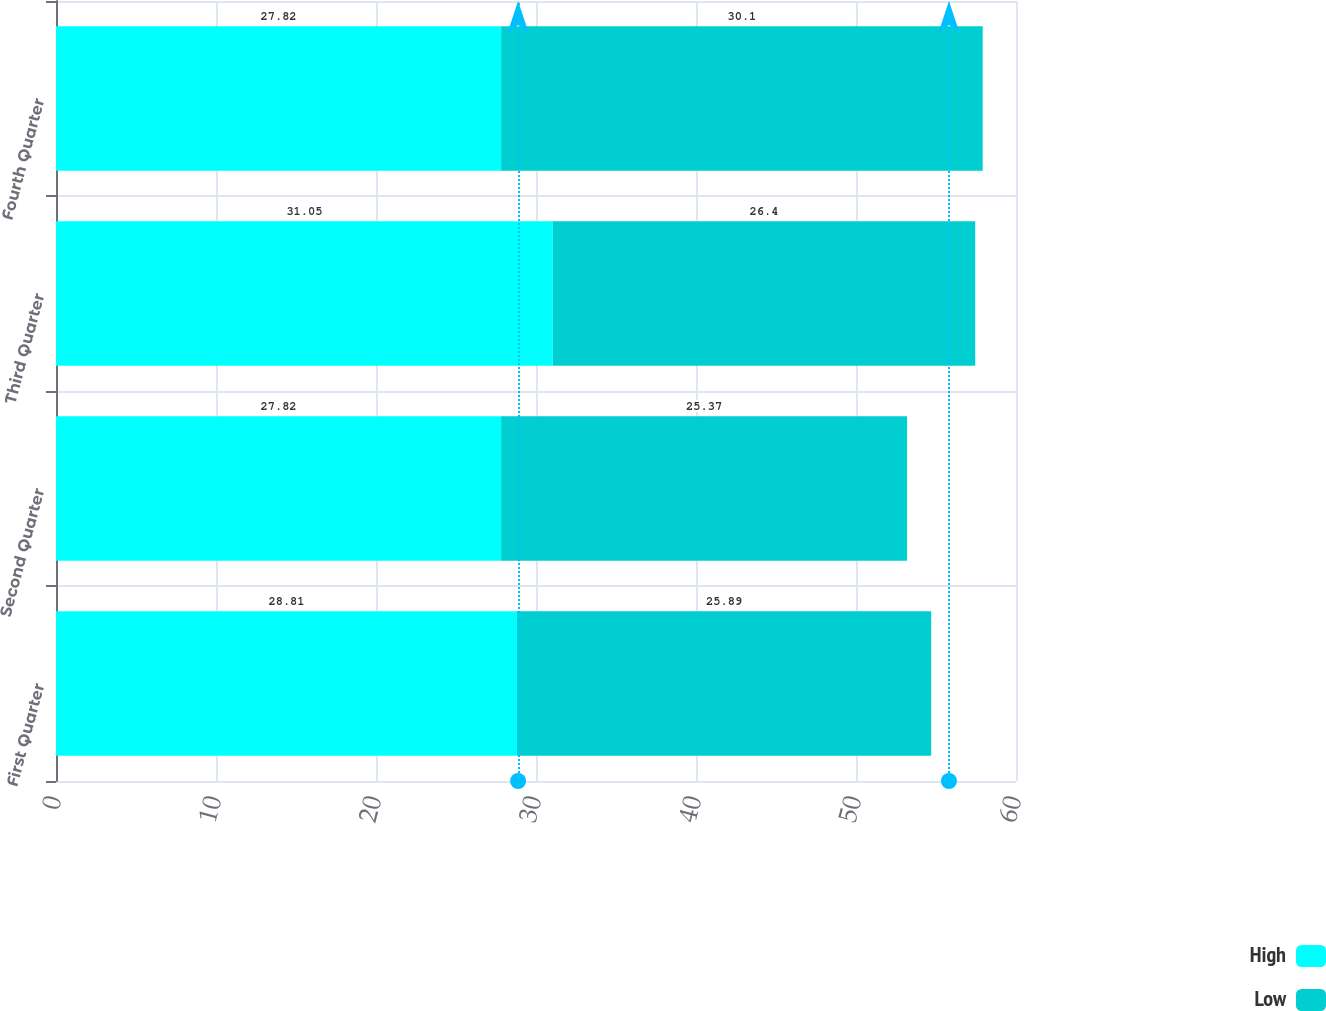Convert chart to OTSL. <chart><loc_0><loc_0><loc_500><loc_500><stacked_bar_chart><ecel><fcel>First Quarter<fcel>Second Quarter<fcel>Third Quarter<fcel>Fourth Quarter<nl><fcel>High<fcel>28.81<fcel>27.82<fcel>31.05<fcel>27.82<nl><fcel>Low<fcel>25.89<fcel>25.37<fcel>26.4<fcel>30.1<nl></chart> 